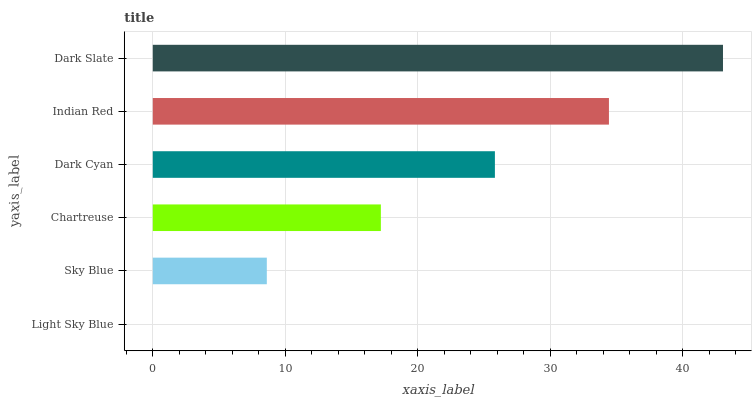Is Light Sky Blue the minimum?
Answer yes or no. Yes. Is Dark Slate the maximum?
Answer yes or no. Yes. Is Sky Blue the minimum?
Answer yes or no. No. Is Sky Blue the maximum?
Answer yes or no. No. Is Sky Blue greater than Light Sky Blue?
Answer yes or no. Yes. Is Light Sky Blue less than Sky Blue?
Answer yes or no. Yes. Is Light Sky Blue greater than Sky Blue?
Answer yes or no. No. Is Sky Blue less than Light Sky Blue?
Answer yes or no. No. Is Dark Cyan the high median?
Answer yes or no. Yes. Is Chartreuse the low median?
Answer yes or no. Yes. Is Sky Blue the high median?
Answer yes or no. No. Is Sky Blue the low median?
Answer yes or no. No. 